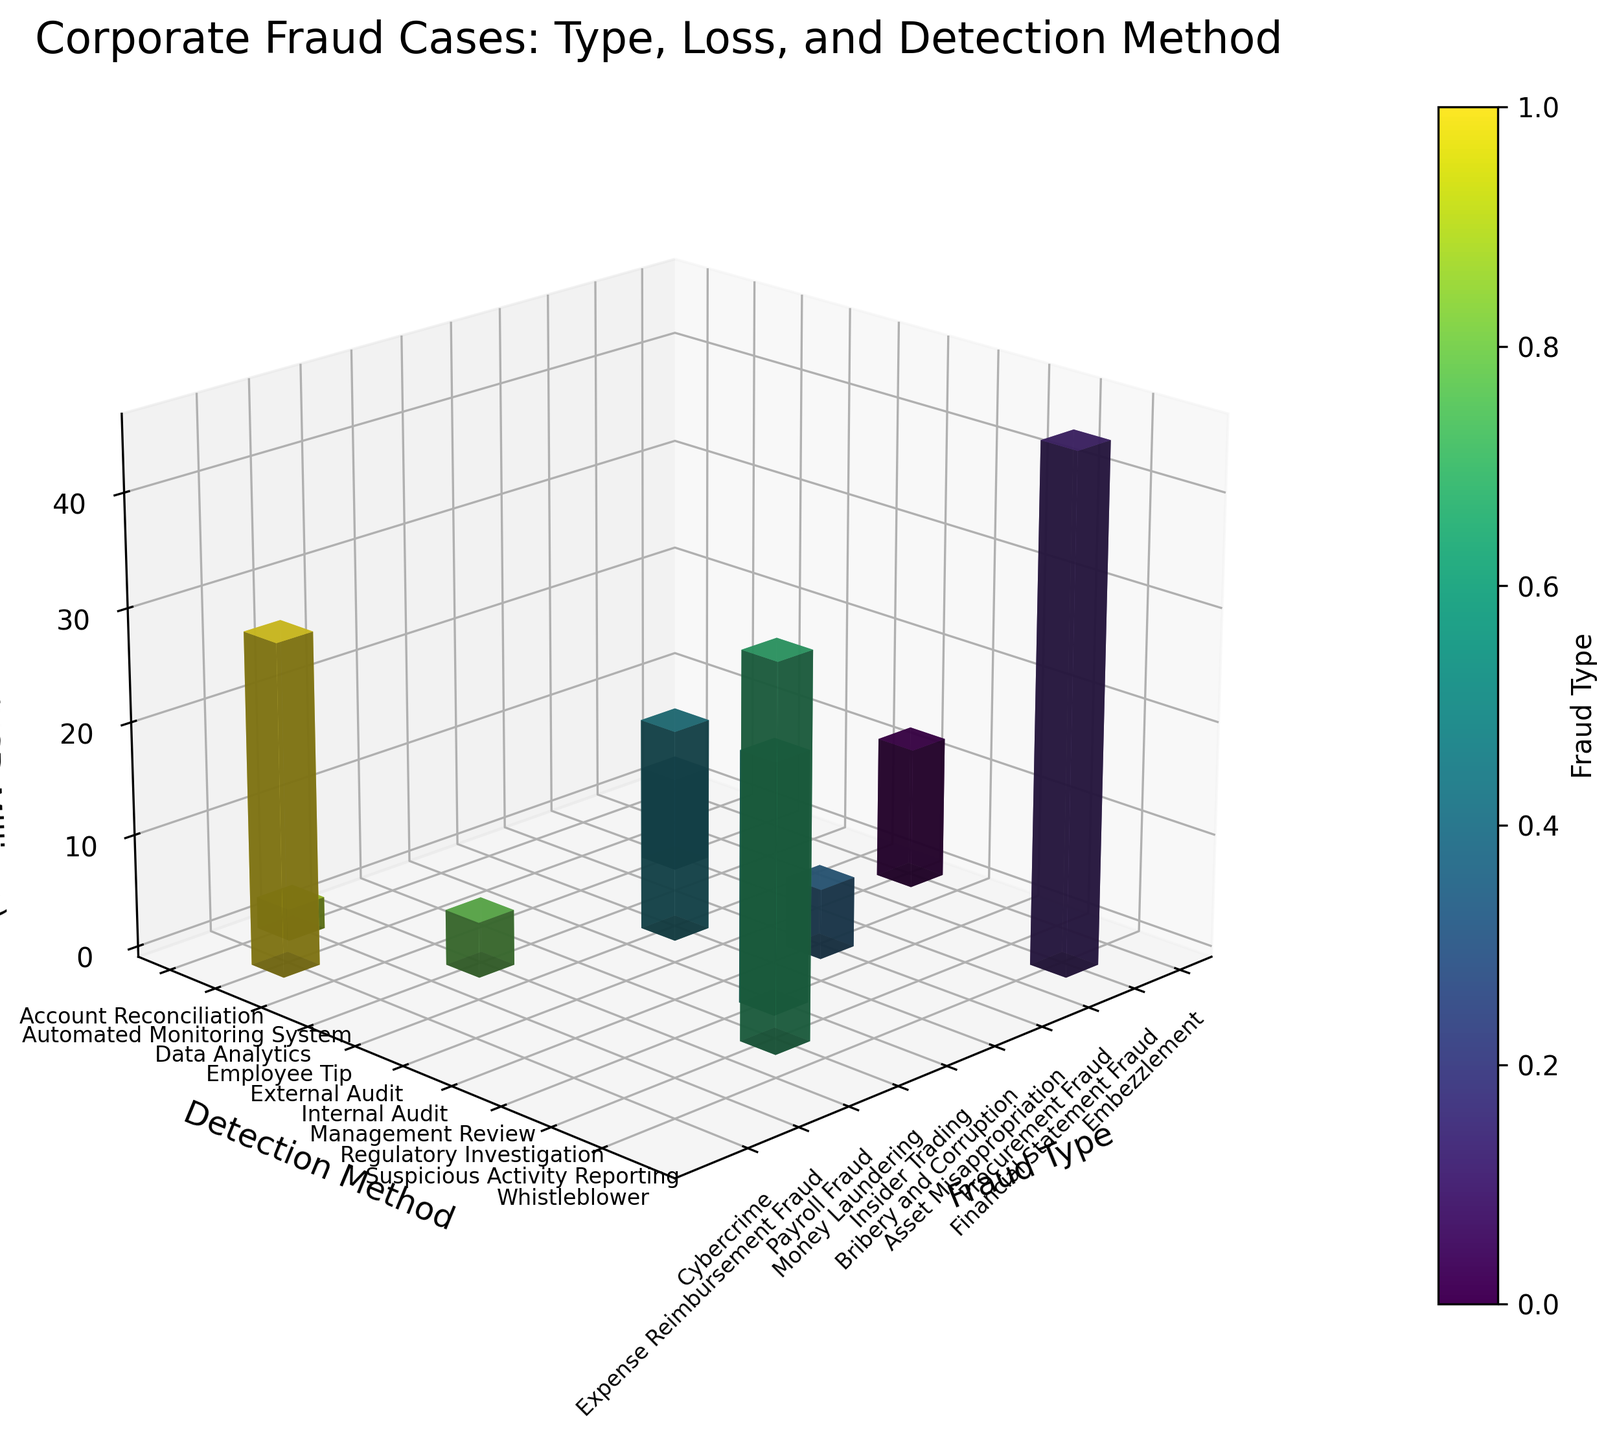how many fraud types are depicted in the plot? The plot has one bar for each distinct fraud type listed on the x-axis. Counting these labels will give the total number of fraud types depicted.
Answer: 10 what is the color scheme used for the bars in the plot? The colors for the bars range through different shades according to the viridis colormap.
Answer: viridis colormap which fraud type has the highest financial loss? By identifying the tallest bar along the z-axis, we see that the 'Financial Statement Fraud' stands out as the highest.
Answer: Financial Statement Fraud what is the detection method for embezzlement? Locate the bar corresponding to 'Embezzlement' on the x-axis, and the y-axis label at the base of that bar is 'Internal Audit'.
Answer: Internal Audit which detection method has the highest cumulative financial loss across all fraud types? Add up the heights of the bars grouped by each detection method and compare the sums. 'Whistleblower' has the highest sum with its only bar for 'Financial Statement Fraud'.
Answer: Whistleblower how many detection methods are shown on the plot? Count the unique y-axis labels to represent the detection methods used for different fraud types.
Answer: 10 what is the total financial loss for all fraud types? Sum of all heights of the bars along the z-axis for each fraud type: 12.5 + 45.8 + 8.3 + 6.2 + 18.7 + 22.1 + 33.6 + 4.9 + 2.8 + 29.4
Answer: 184.3 which fraud type detected by 'Management Review' has the lowest financial loss? Locate the bars linked to the 'Management Review' on the yz-plane and compare the heights. 'Asset Misappropriation' has the lowest height among them.
Answer: Asset Misappropriation what is the average financial loss of cases involving 'External Audit'? Locate the relevant bar for 'External Audit' and take the single height value, as there's only one bar: 18.7
Answer: 18.7 compare the financial loss of 'Cybercrime' detected by 'Automated Monitoring System' and 'Money Laundering' detected by 'Suspicious Activity Reporting'. Which is higher and by how much? 'Cybercrime' has a loss of 29.4 million, while 'Money Laundering' has 33.6 million. The difference is 33.6 - 29.4.
Answer: Money Laundering, 4.2 